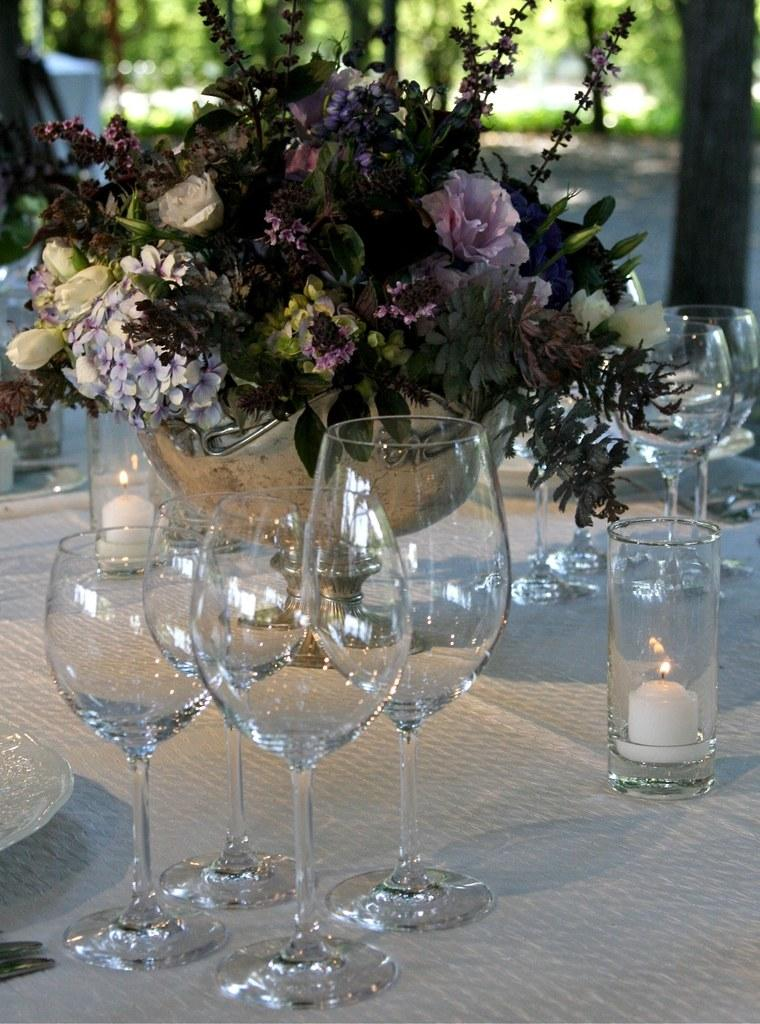What piece of furniture is present in the image? There is a table in the image. What items can be seen on the table? There are glasses, a candle, a plate, a knife, and a flower pot on the table. What is inside the flower pot? The flower pot contains various kinds of flowers. How many houses are visible in the image? There are no houses visible in the image; it only features a table with various items on it. What type of waste is present in the image? There is no waste present in the image; it only features a table with various items on it. 